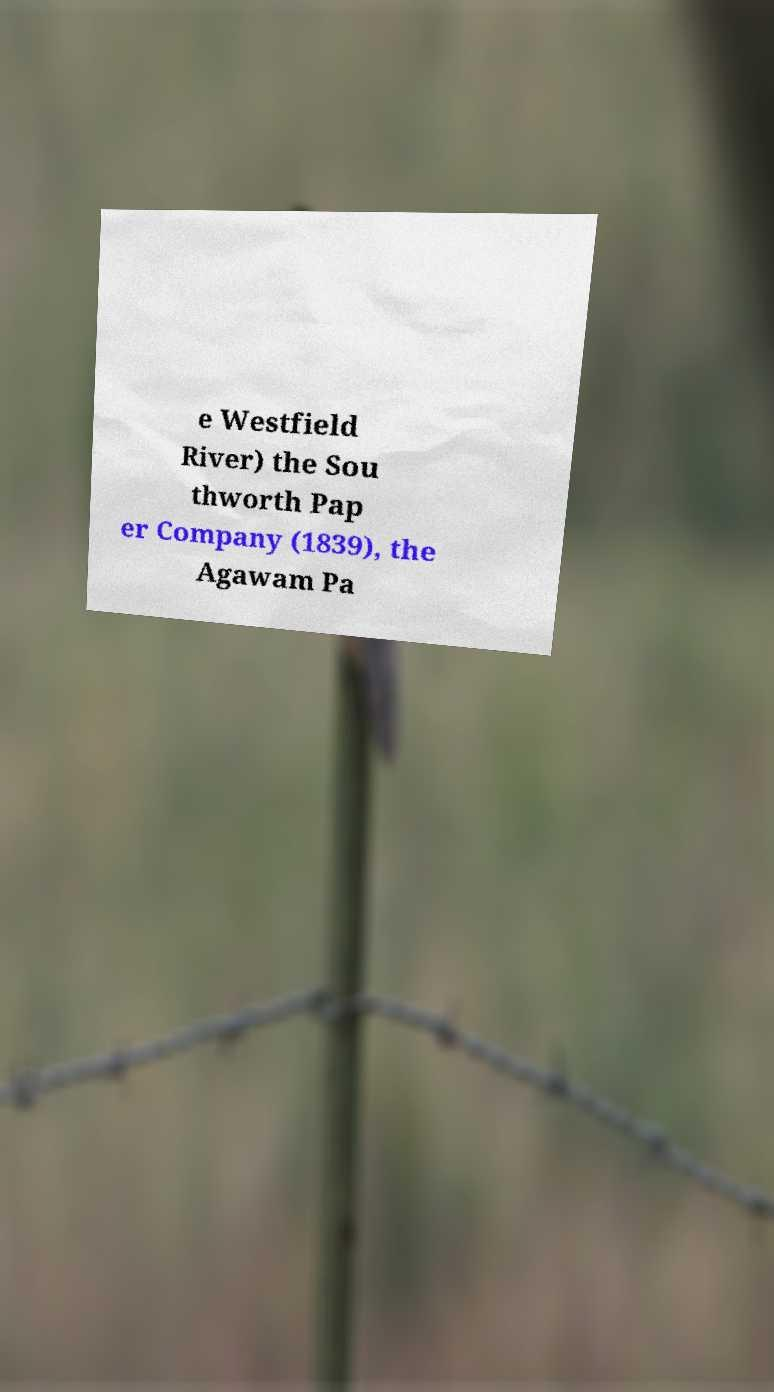Can you accurately transcribe the text from the provided image for me? e Westfield River) the Sou thworth Pap er Company (1839), the Agawam Pa 